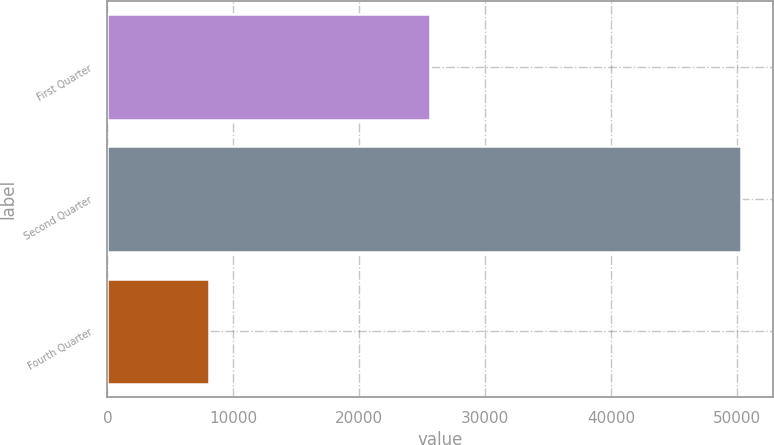Convert chart to OTSL. <chart><loc_0><loc_0><loc_500><loc_500><bar_chart><fcel>First Quarter<fcel>Second Quarter<fcel>Fourth Quarter<nl><fcel>25608<fcel>50298<fcel>8040<nl></chart> 